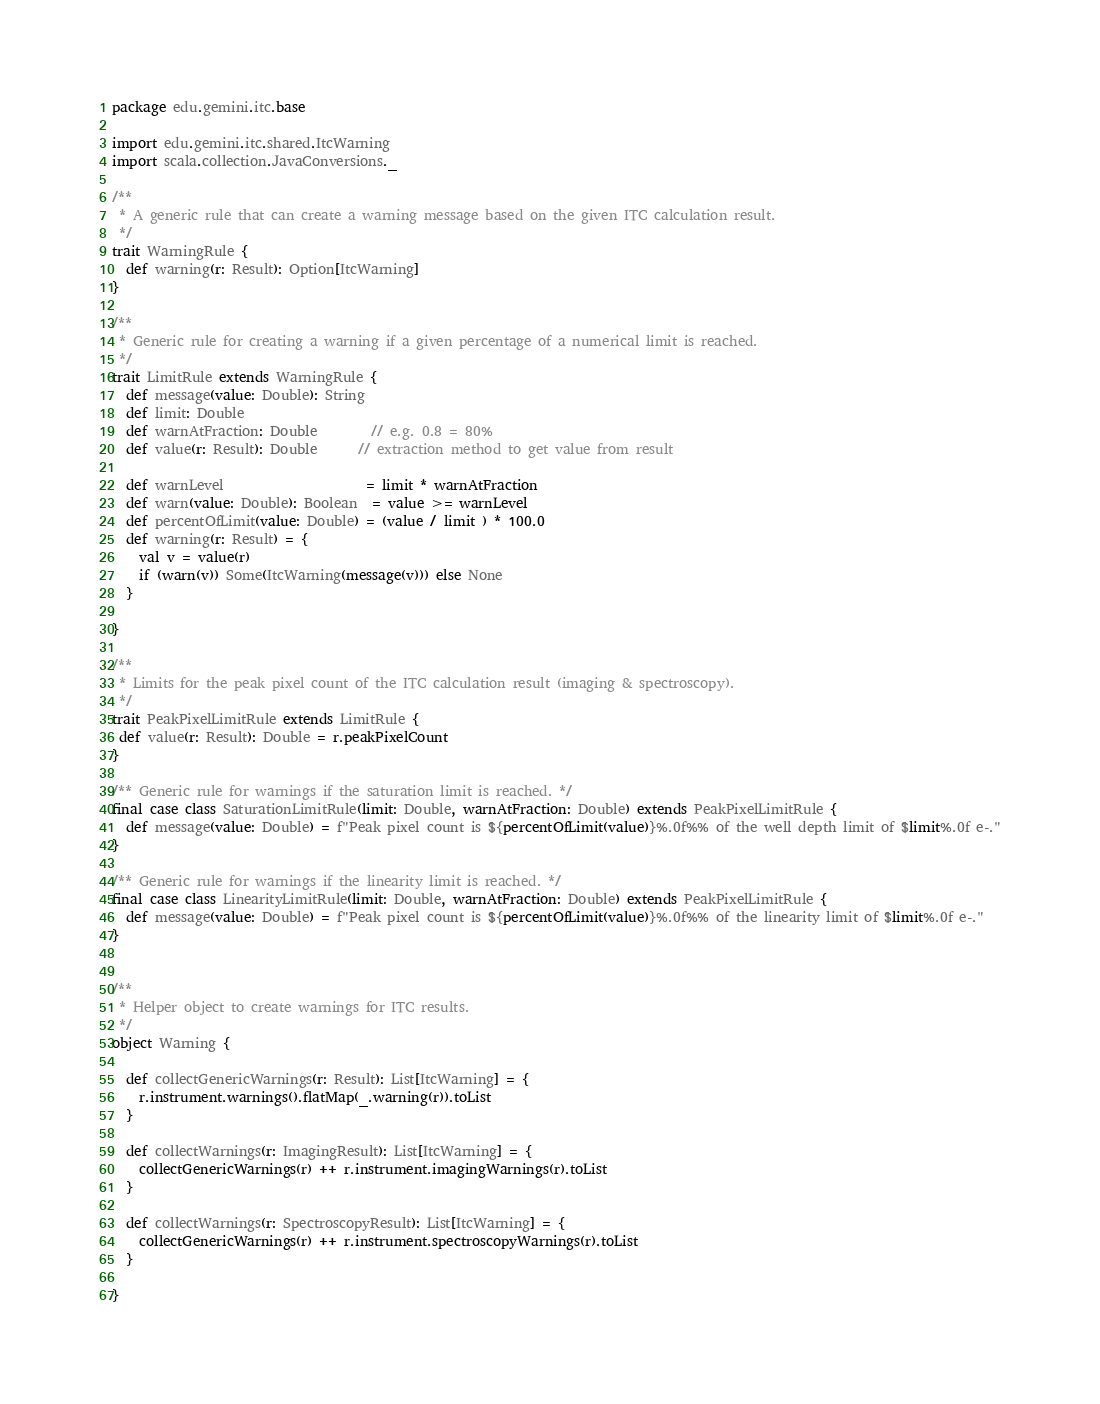<code> <loc_0><loc_0><loc_500><loc_500><_Scala_>package edu.gemini.itc.base

import edu.gemini.itc.shared.ItcWarning
import scala.collection.JavaConversions._

/**
 * A generic rule that can create a warning message based on the given ITC calculation result.
 */
trait WarningRule {
  def warning(r: Result): Option[ItcWarning]
}

/**
 * Generic rule for creating a warning if a given percentage of a numerical limit is reached.
 */
trait LimitRule extends WarningRule {
  def message(value: Double): String
  def limit: Double
  def warnAtFraction: Double        // e.g. 0.8 = 80%
  def value(r: Result): Double      // extraction method to get value from result

  def warnLevel                     = limit * warnAtFraction
  def warn(value: Double): Boolean  = value >= warnLevel
  def percentOfLimit(value: Double) = (value / limit ) * 100.0
  def warning(r: Result) = {
    val v = value(r)
    if (warn(v)) Some(ItcWarning(message(v))) else None
  }

}

/**
 * Limits for the peak pixel count of the ITC calculation result (imaging & spectroscopy).
 */
trait PeakPixelLimitRule extends LimitRule {
 def value(r: Result): Double = r.peakPixelCount
}

/** Generic rule for warnings if the saturation limit is reached. */
final case class SaturationLimitRule(limit: Double, warnAtFraction: Double) extends PeakPixelLimitRule {
  def message(value: Double) = f"Peak pixel count is ${percentOfLimit(value)}%.0f%% of the well depth limit of $limit%.0f e-."
}

/** Generic rule for warnings if the linearity limit is reached. */
final case class LinearityLimitRule(limit: Double, warnAtFraction: Double) extends PeakPixelLimitRule {
  def message(value: Double) = f"Peak pixel count is ${percentOfLimit(value)}%.0f%% of the linearity limit of $limit%.0f e-."
}


/**
 * Helper object to create warnings for ITC results.
 */
object Warning {

  def collectGenericWarnings(r: Result): List[ItcWarning] = {
    r.instrument.warnings().flatMap(_.warning(r)).toList
  }

  def collectWarnings(r: ImagingResult): List[ItcWarning] = {
    collectGenericWarnings(r) ++ r.instrument.imagingWarnings(r).toList
  }

  def collectWarnings(r: SpectroscopyResult): List[ItcWarning] = {
    collectGenericWarnings(r) ++ r.instrument.spectroscopyWarnings(r).toList
  }

}

</code> 